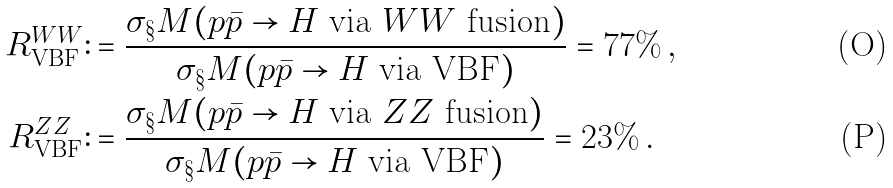<formula> <loc_0><loc_0><loc_500><loc_500>R _ { \text {VBF} } ^ { W W } & \colon = \frac { \sigma _ { \S } M ( p \bar { p } \to H \text { via $WW$ fusion} ) } { \sigma _ { \S } M ( p \bar { p } \to H \text { via VBF} ) } = 7 7 \% \, , \\ R _ { \text {VBF} } ^ { Z Z } & \colon = \frac { \sigma _ { \S } M ( p \bar { p } \to H \text { via $ZZ$ fusion} ) } { \sigma _ { \S } M ( p \bar { p } \to H \text { via VBF} ) } = 2 3 \% \, .</formula> 